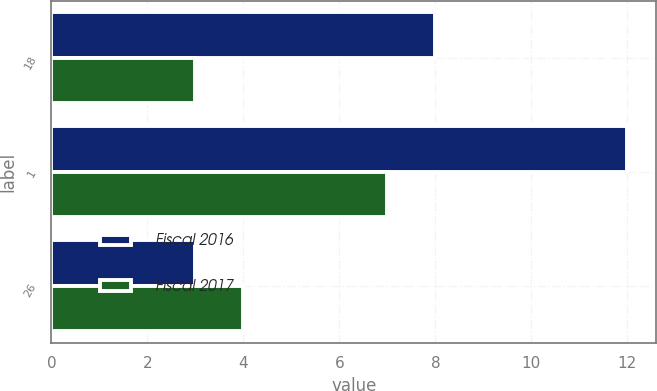Convert chart. <chart><loc_0><loc_0><loc_500><loc_500><stacked_bar_chart><ecel><fcel>18<fcel>1<fcel>26<nl><fcel>Fiscal 2016<fcel>8<fcel>12<fcel>3<nl><fcel>Fiscal 2017<fcel>3<fcel>7<fcel>4<nl></chart> 